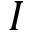Convert formula to latex. <formula><loc_0><loc_0><loc_500><loc_500>I</formula> 